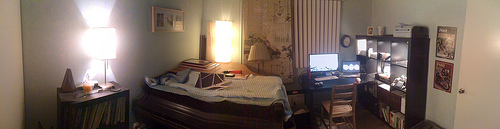Please provide the bounding box coordinate of the region this sentence describes: A sharp light from the window. For the sharp light emanating from the window, more precise coordinates would account for the brightest part of the light, perhaps [0.15, 0.40, 0.22, 0.49], highlighting the area where the light intensity peaks. 